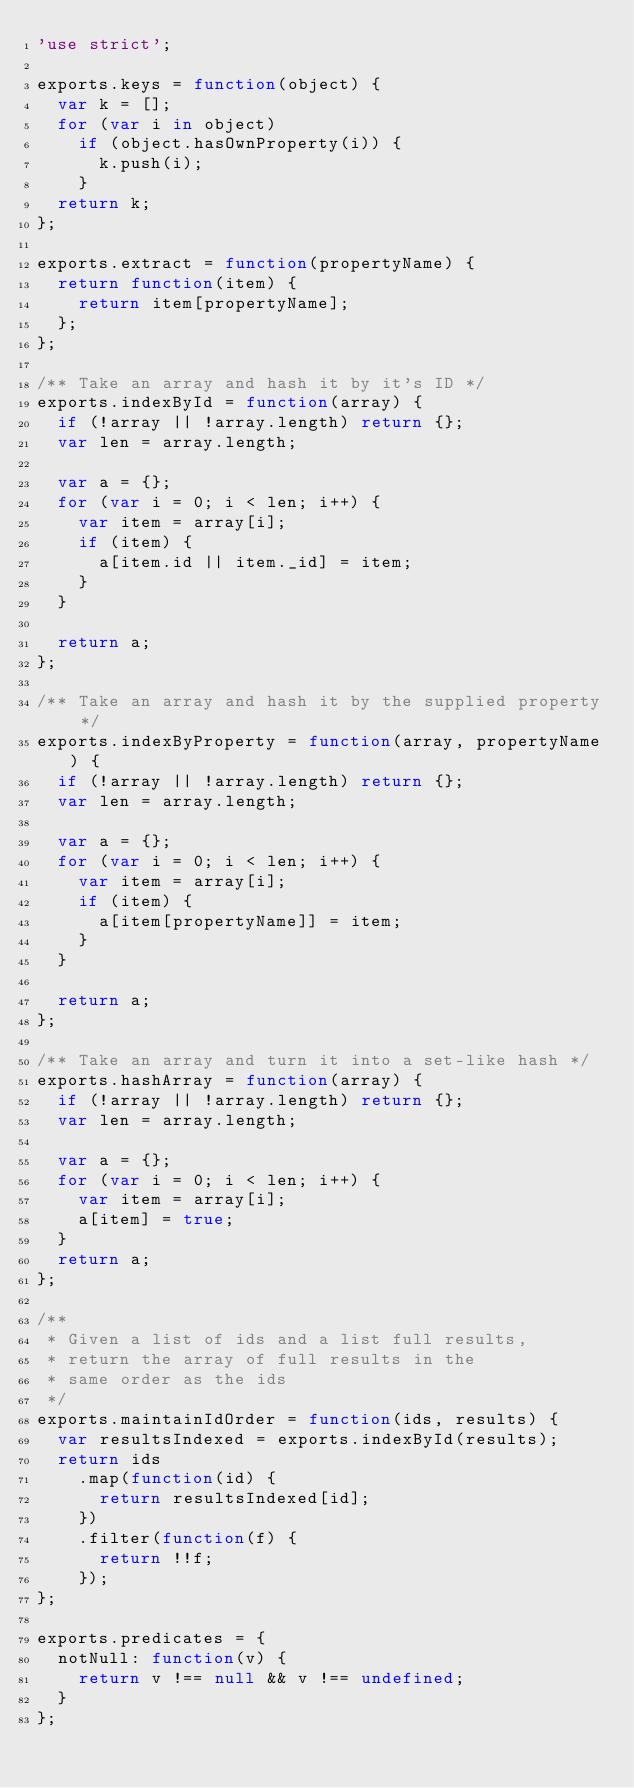<code> <loc_0><loc_0><loc_500><loc_500><_JavaScript_>'use strict';

exports.keys = function(object) {
  var k = [];
  for (var i in object)
    if (object.hasOwnProperty(i)) {
      k.push(i);
    }
  return k;
};

exports.extract = function(propertyName) {
  return function(item) {
    return item[propertyName];
  };
};

/** Take an array and hash it by it's ID */
exports.indexById = function(array) {
  if (!array || !array.length) return {};
  var len = array.length;

  var a = {};
  for (var i = 0; i < len; i++) {
    var item = array[i];
    if (item) {
      a[item.id || item._id] = item;
    }
  }

  return a;
};

/** Take an array and hash it by the supplied property */
exports.indexByProperty = function(array, propertyName) {
  if (!array || !array.length) return {};
  var len = array.length;

  var a = {};
  for (var i = 0; i < len; i++) {
    var item = array[i];
    if (item) {
      a[item[propertyName]] = item;
    }
  }

  return a;
};

/** Take an array and turn it into a set-like hash */
exports.hashArray = function(array) {
  if (!array || !array.length) return {};
  var len = array.length;

  var a = {};
  for (var i = 0; i < len; i++) {
    var item = array[i];
    a[item] = true;
  }
  return a;
};

/**
 * Given a list of ids and a list full results,
 * return the array of full results in the
 * same order as the ids
 */
exports.maintainIdOrder = function(ids, results) {
  var resultsIndexed = exports.indexById(results);
  return ids
    .map(function(id) {
      return resultsIndexed[id];
    })
    .filter(function(f) {
      return !!f;
    });
};

exports.predicates = {
  notNull: function(v) {
    return v !== null && v !== undefined;
  }
};
</code> 